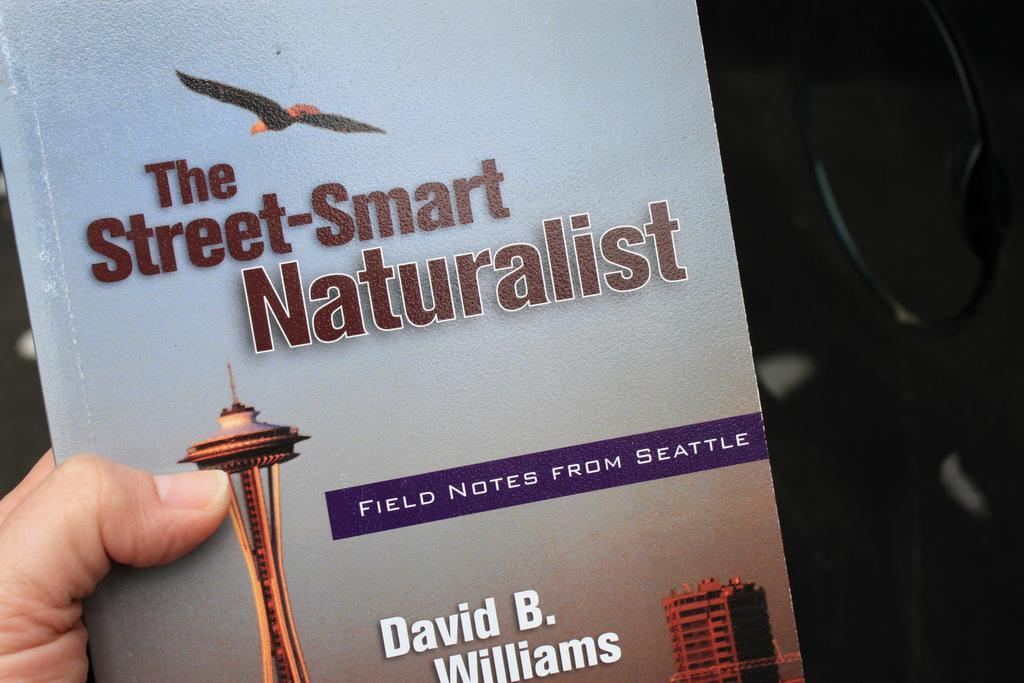<image>
Write a terse but informative summary of the picture. Person holding a book titled "The Street-Smart Naturalist" with a bird flying on the cover. 